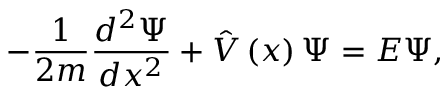<formula> <loc_0><loc_0><loc_500><loc_500>- \frac { 1 } 2 m } \frac { d ^ { 2 } \Psi } { d x ^ { 2 } } + \hat { V } \left ( x \right ) \Psi = E \Psi ,</formula> 